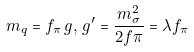Convert formula to latex. <formula><loc_0><loc_0><loc_500><loc_500>m _ { q } = f _ { \pi } \, g , \, g ^ { \prime } = \frac { m _ { \sigma } ^ { 2 } } { 2 f \pi } = \lambda f _ { \pi }</formula> 